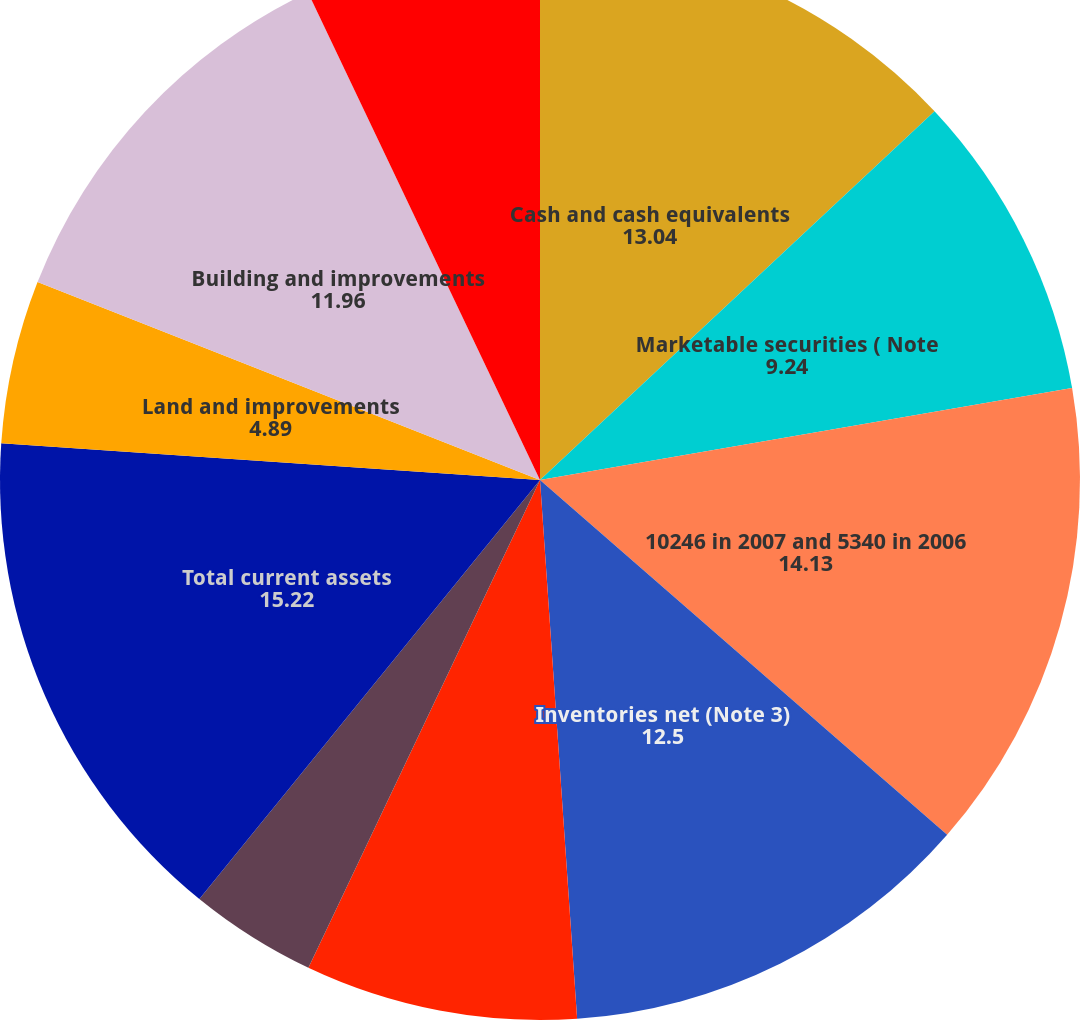Convert chart to OTSL. <chart><loc_0><loc_0><loc_500><loc_500><pie_chart><fcel>Cash and cash equivalents<fcel>Marketable securities ( Note<fcel>10246 in 2007 and 5340 in 2006<fcel>Inventories net (Note 3)<fcel>Deferred income taxes (Note 7)<fcel>Prepaid expenses and other<fcel>Total current assets<fcel>Land and improvements<fcel>Building and improvements<fcel>Office furniture and equipment<nl><fcel>13.04%<fcel>9.24%<fcel>14.13%<fcel>12.5%<fcel>8.15%<fcel>3.81%<fcel>15.22%<fcel>4.89%<fcel>11.96%<fcel>7.07%<nl></chart> 